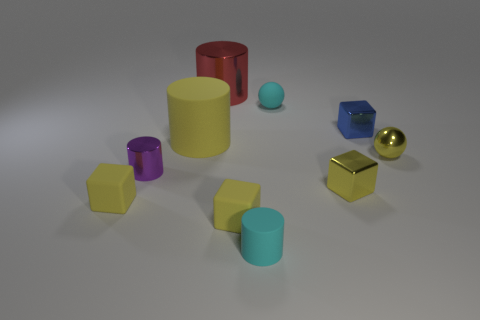There is a blue thing that is the same material as the small purple object; what size is it?
Your answer should be very brief. Small. Is the number of big red metal objects less than the number of large yellow rubber spheres?
Your answer should be very brief. No. What material is the blue object that is the same size as the purple metallic thing?
Make the answer very short. Metal. Are there more big shiny things than brown balls?
Make the answer very short. Yes. How many other objects are there of the same color as the tiny matte cylinder?
Offer a terse response. 1. How many tiny yellow objects are both on the right side of the red metallic cylinder and in front of the small yellow ball?
Provide a succinct answer. 2. Are there more tiny yellow things that are to the left of the big metallic cylinder than yellow matte things to the right of the tiny cyan matte cylinder?
Provide a succinct answer. Yes. There is a tiny cyan thing that is in front of the purple metal object; what is its material?
Provide a short and direct response. Rubber. There is a blue object; is its shape the same as the yellow matte thing that is right of the big red object?
Your answer should be compact. Yes. What number of matte cylinders are right of the small matte block to the right of the matte block on the left side of the yellow rubber cylinder?
Your answer should be compact. 1. 